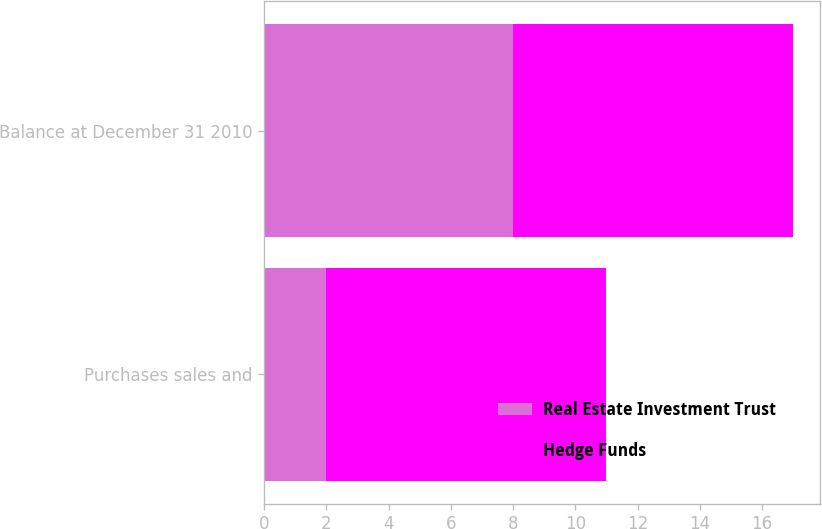Convert chart. <chart><loc_0><loc_0><loc_500><loc_500><stacked_bar_chart><ecel><fcel>Purchases sales and<fcel>Balance at December 31 2010<nl><fcel>Real Estate Investment Trust<fcel>2<fcel>8<nl><fcel>Hedge Funds<fcel>9<fcel>9<nl></chart> 